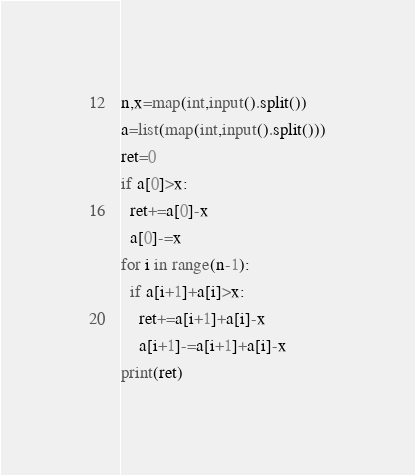Convert code to text. <code><loc_0><loc_0><loc_500><loc_500><_Python_>n,x=map(int,input().split())
a=list(map(int,input().split()))
ret=0
if a[0]>x:
  ret+=a[0]-x
  a[0]-=x
for i in range(n-1):
  if a[i+1]+a[i]>x:
    ret+=a[i+1]+a[i]-x
    a[i+1]-=a[i+1]+a[i]-x
print(ret)</code> 